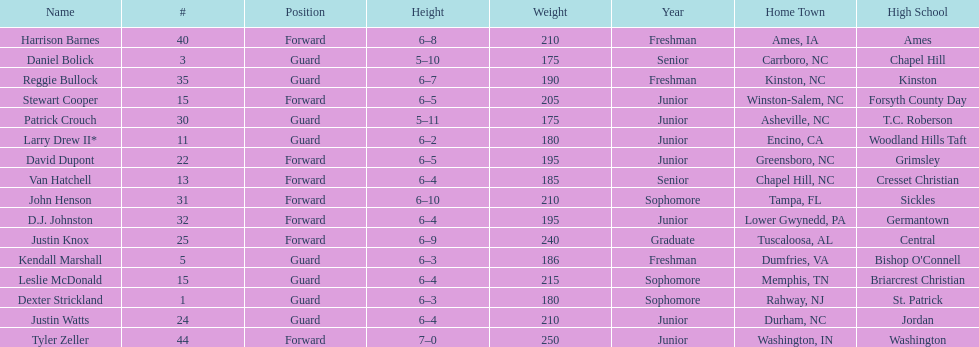Total number of players whose home town was in north carolina (nc) 7. 